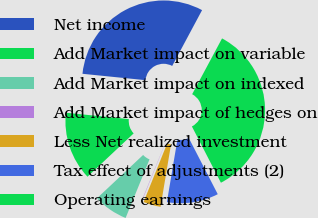Convert chart to OTSL. <chart><loc_0><loc_0><loc_500><loc_500><pie_chart><fcel>Net income<fcel>Add Market impact on variable<fcel>Add Market impact on indexed<fcel>Add Market impact of hedges on<fcel>Less Net realized investment<fcel>Tax effect of adjustments (2)<fcel>Operating earnings<nl><fcel>31.22%<fcel>13.6%<fcel>6.84%<fcel>0.07%<fcel>3.45%<fcel>10.22%<fcel>34.6%<nl></chart> 